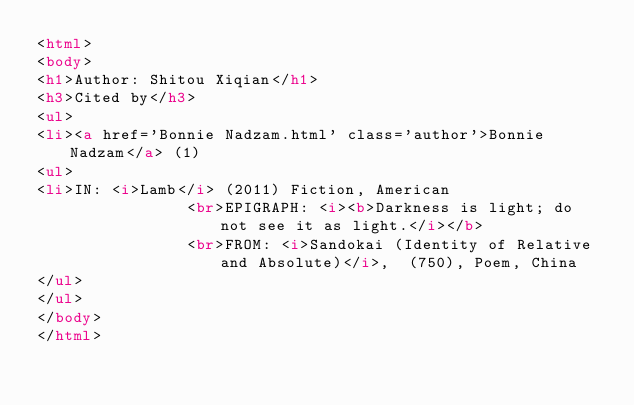Convert code to text. <code><loc_0><loc_0><loc_500><loc_500><_HTML_><html>
<body>
<h1>Author: Shitou Xiqian</h1>
<h3>Cited by</h3>
<ul>
<li><a href='Bonnie Nadzam.html' class='author'>Bonnie Nadzam</a> (1)
<ul>
<li>IN: <i>Lamb</i> (2011) Fiction, American
                <br>EPIGRAPH: <i><b>Darkness is light; do not see it as light.</i></b>
                <br>FROM: <i>Sandokai (Identity of Relative and Absolute)</i>,  (750), Poem, China
</ul>
</ul>
</body>
</html>
</code> 